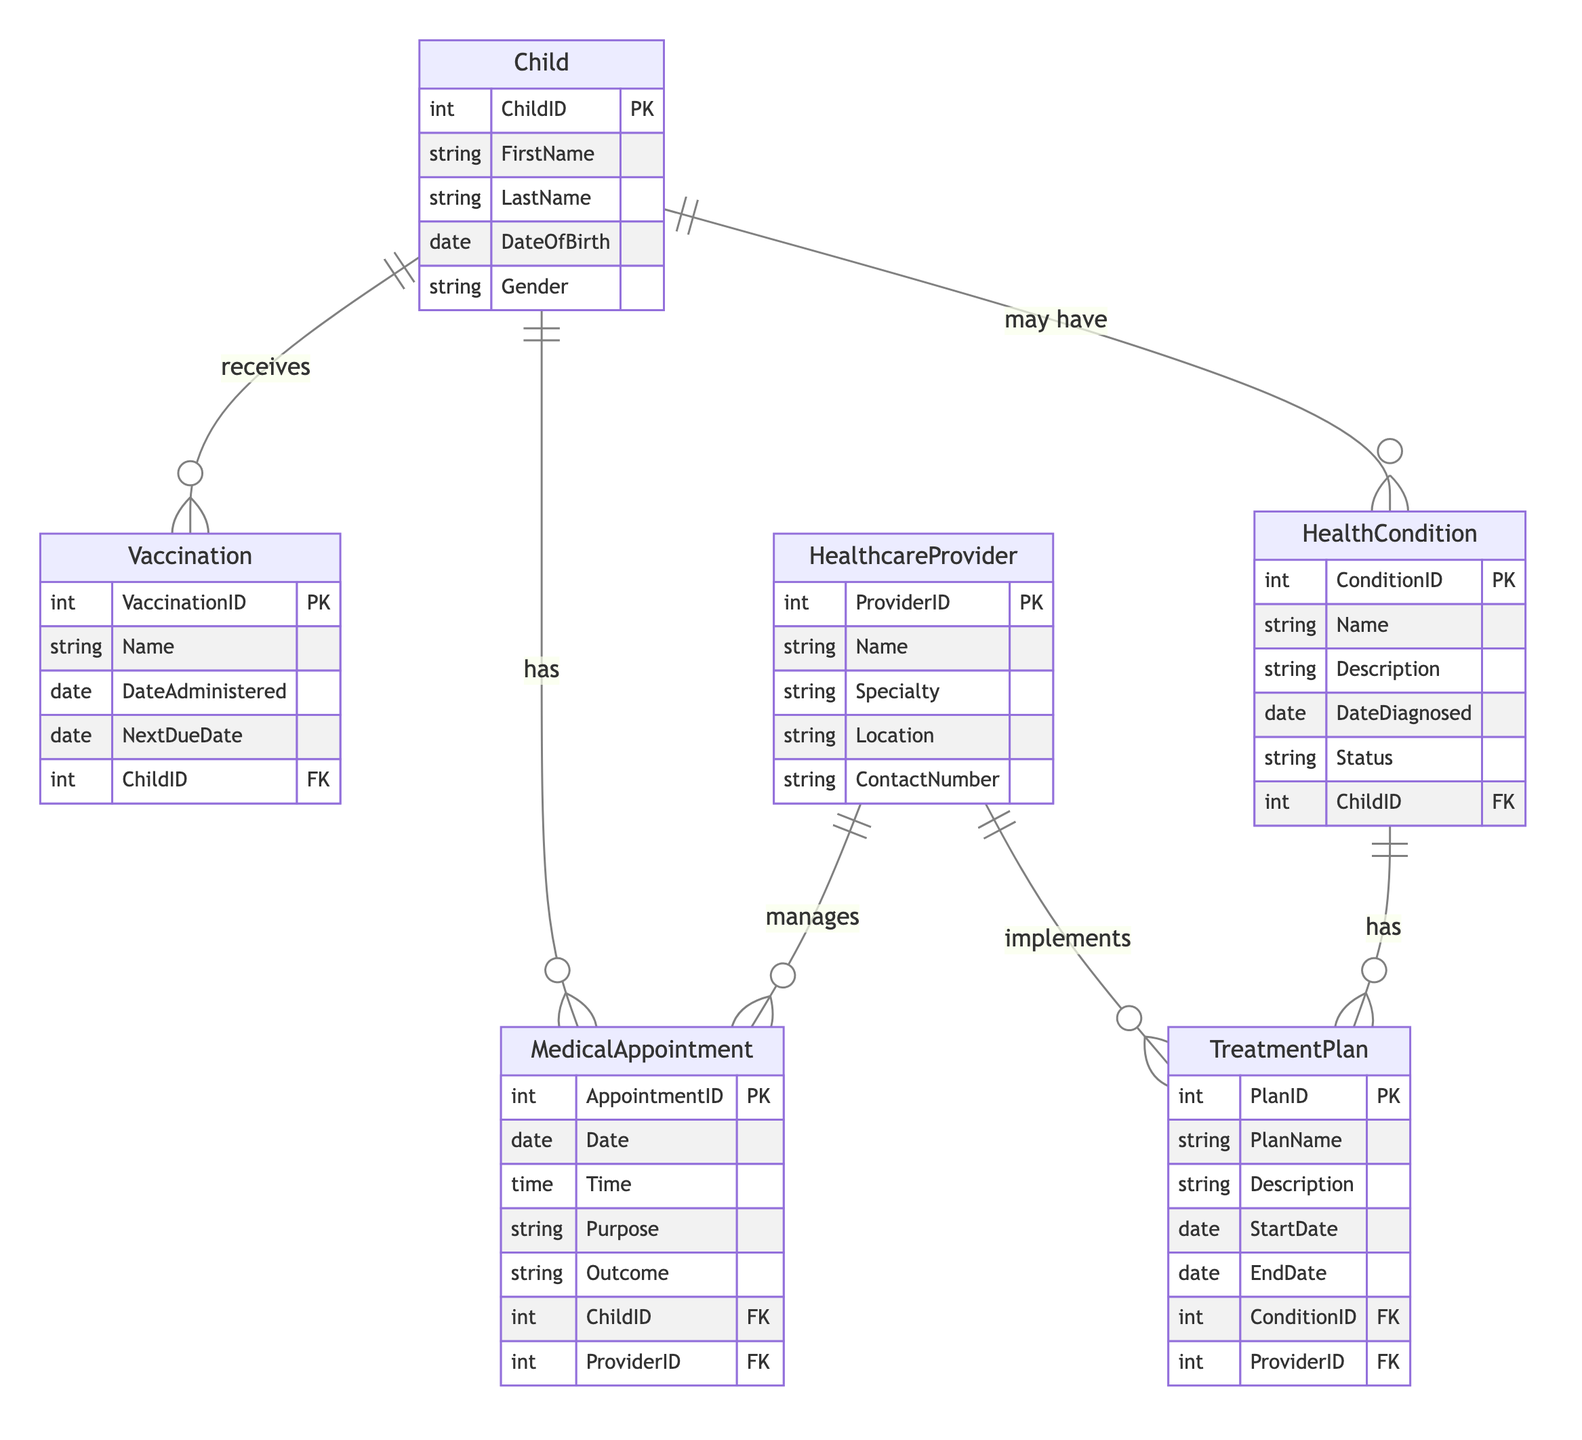What is the primary identifier for a Child? The primary identifier for a Child entity in the diagram is "ChildID." This is indicated in the attributes listed for the Child entity where ChildID is marked as PK (Primary Key).
Answer: ChildID How many entities are related to HealthCondition? The HealthCondition entity is related to three other entities: Child, TreatmentPlan, and HealthcareProvider (indirectly through TreatmentPlan). Counting these relationships gives us a total of three entities.
Answer: 3 Which entity administers vaccinations to children? The entity that administers vaccinations is the "Child" entity. This is shown in the relationship labeled "ChildHasVaccination," indicating that a child receives vaccinations.
Answer: Child How many types of medical appointments can a child have? A child can have multiple medical appointments; each appointment is linked to a specific child through the relationship "ChildHasMedicalAppointment," which indicates a one-to-many relationship. Therefore, there is no limit defined in the diagram, but the direct answer is that it can be many.
Answer: Many What connects HealthcareProvider and MedicalAppointment? The connection between HealthcareProvider and MedicalAppointment is indicated by the relationship "HealthcareProviderManagesMedicalAppointment," which signifies that a healthcare provider manages multiple medical appointments.
Answer: Manages What is the function of the TreatmentPlan in relation to HealthCondition? The TreatmentPlan is related to HealthCondition through the relationship "HealthConditionHasTreatmentPlan," indicating that each health condition can have one or more associated treatment plans.
Answer: Has How many attributes does the MedicalAppointment entity contain? The MedicalAppointment entity contains five attributes as shown in the entity description: AppointmentID, Date, Time, Purpose, and Outcome. Counting these gives a total of five attributes.
Answer: 5 What type of relationship exists between Child and Vaccination? The relationship between Child and Vaccination is a one-to-many relationship, indicated by "ChildHasVaccination," which means that one child can receive multiple vaccinations.
Answer: 1:N Which entity is primarily responsible for implementing treatment plans? The entity primarily responsible for implementing treatment plans is "HealthcareProvider." This is shown in the relationship "HealthcareProviderImplementsTreatmentPlan," indicating that healthcare providers implement treatment plans.
Answer: HealthcareProvider 